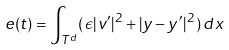Convert formula to latex. <formula><loc_0><loc_0><loc_500><loc_500>e ( t ) = \int _ { T ^ { d } } ( \, \epsilon | v ^ { \prime } | ^ { 2 } + | y - y ^ { \prime } | ^ { 2 } \, ) \, d x</formula> 